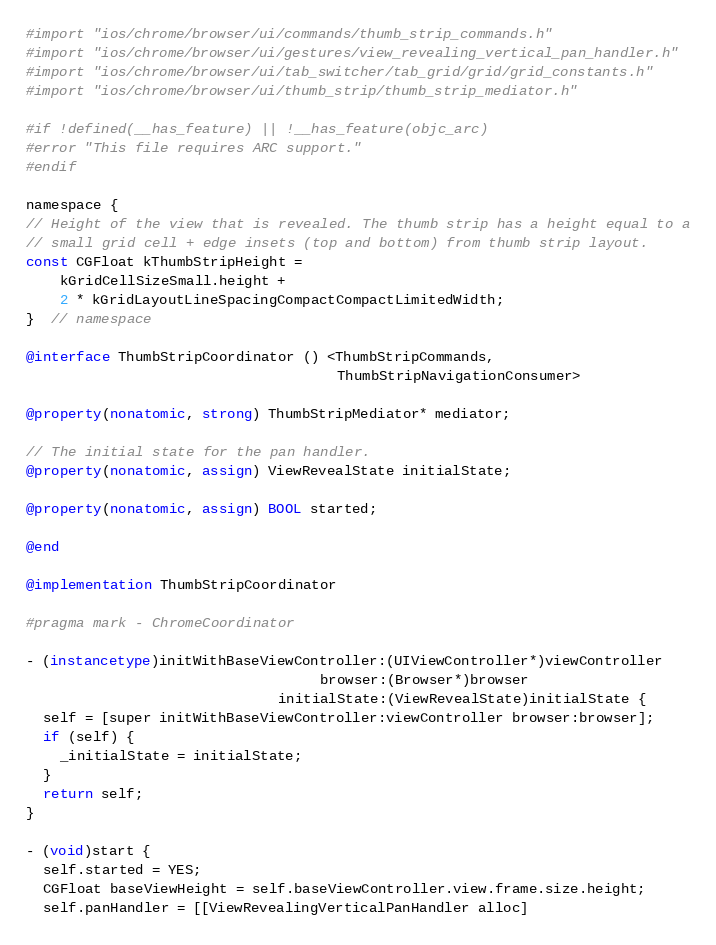<code> <loc_0><loc_0><loc_500><loc_500><_ObjectiveC_>#import "ios/chrome/browser/ui/commands/thumb_strip_commands.h"
#import "ios/chrome/browser/ui/gestures/view_revealing_vertical_pan_handler.h"
#import "ios/chrome/browser/ui/tab_switcher/tab_grid/grid/grid_constants.h"
#import "ios/chrome/browser/ui/thumb_strip/thumb_strip_mediator.h"

#if !defined(__has_feature) || !__has_feature(objc_arc)
#error "This file requires ARC support."
#endif

namespace {
// Height of the view that is revealed. The thumb strip has a height equal to a
// small grid cell + edge insets (top and bottom) from thumb strip layout.
const CGFloat kThumbStripHeight =
    kGridCellSizeSmall.height +
    2 * kGridLayoutLineSpacingCompactCompactLimitedWidth;
}  // namespace

@interface ThumbStripCoordinator () <ThumbStripCommands,
                                     ThumbStripNavigationConsumer>

@property(nonatomic, strong) ThumbStripMediator* mediator;

// The initial state for the pan handler.
@property(nonatomic, assign) ViewRevealState initialState;

@property(nonatomic, assign) BOOL started;

@end

@implementation ThumbStripCoordinator

#pragma mark - ChromeCoordinator

- (instancetype)initWithBaseViewController:(UIViewController*)viewController
                                   browser:(Browser*)browser
                              initialState:(ViewRevealState)initialState {
  self = [super initWithBaseViewController:viewController browser:browser];
  if (self) {
    _initialState = initialState;
  }
  return self;
}

- (void)start {
  self.started = YES;
  CGFloat baseViewHeight = self.baseViewController.view.frame.size.height;
  self.panHandler = [[ViewRevealingVerticalPanHandler alloc]</code> 